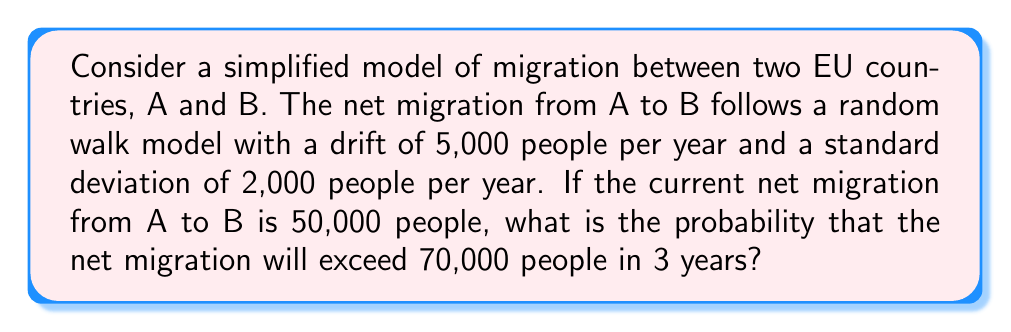Solve this math problem. Let's approach this step-by-step:

1) In a random walk model with drift, the expected value after $n$ steps is:
   $$E[X_n] = X_0 + n\mu$$
   where $X_0$ is the initial value, $n$ is the number of steps, and $\mu$ is the drift.

2) The variance after $n$ steps is:
   $$Var[X_n] = n\sigma^2$$
   where $\sigma$ is the standard deviation per step.

3) In our case:
   $X_0 = 50,000$
   $n = 3$ (years)
   $\mu = 5,000$ (people per year)
   $\sigma = 2,000$ (people per year)

4) The expected value after 3 years is:
   $$E[X_3] = 50,000 + 3 * 5,000 = 65,000$$

5) The variance after 3 years is:
   $$Var[X_3] = 3 * 2,000^2 = 12,000,000$$

6) The standard deviation is:
   $$\sqrt{Var[X_3]} = \sqrt{12,000,000} = 3,464.1016$$

7) We want to find $P(X_3 > 70,000)$. We can standardize this:
   $$Z = \frac{X_3 - E[X_3]}{\sqrt{Var[X_3]}} = \frac{70,000 - 65,000}{3,464.1016} = 1.4433$$

8) The probability is then:
   $$P(X_3 > 70,000) = P(Z > 1.4433) = 1 - \Phi(1.4433)$$
   where $\Phi$ is the standard normal cumulative distribution function.

9) Using a standard normal table or calculator, we find:
   $$1 - \Phi(1.4433) \approx 0.0745$$

Therefore, the probability that the net migration will exceed 70,000 people in 3 years is approximately 0.0745 or 7.45%.
Answer: 0.0745 